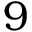<formula> <loc_0><loc_0><loc_500><loc_500>9</formula> 